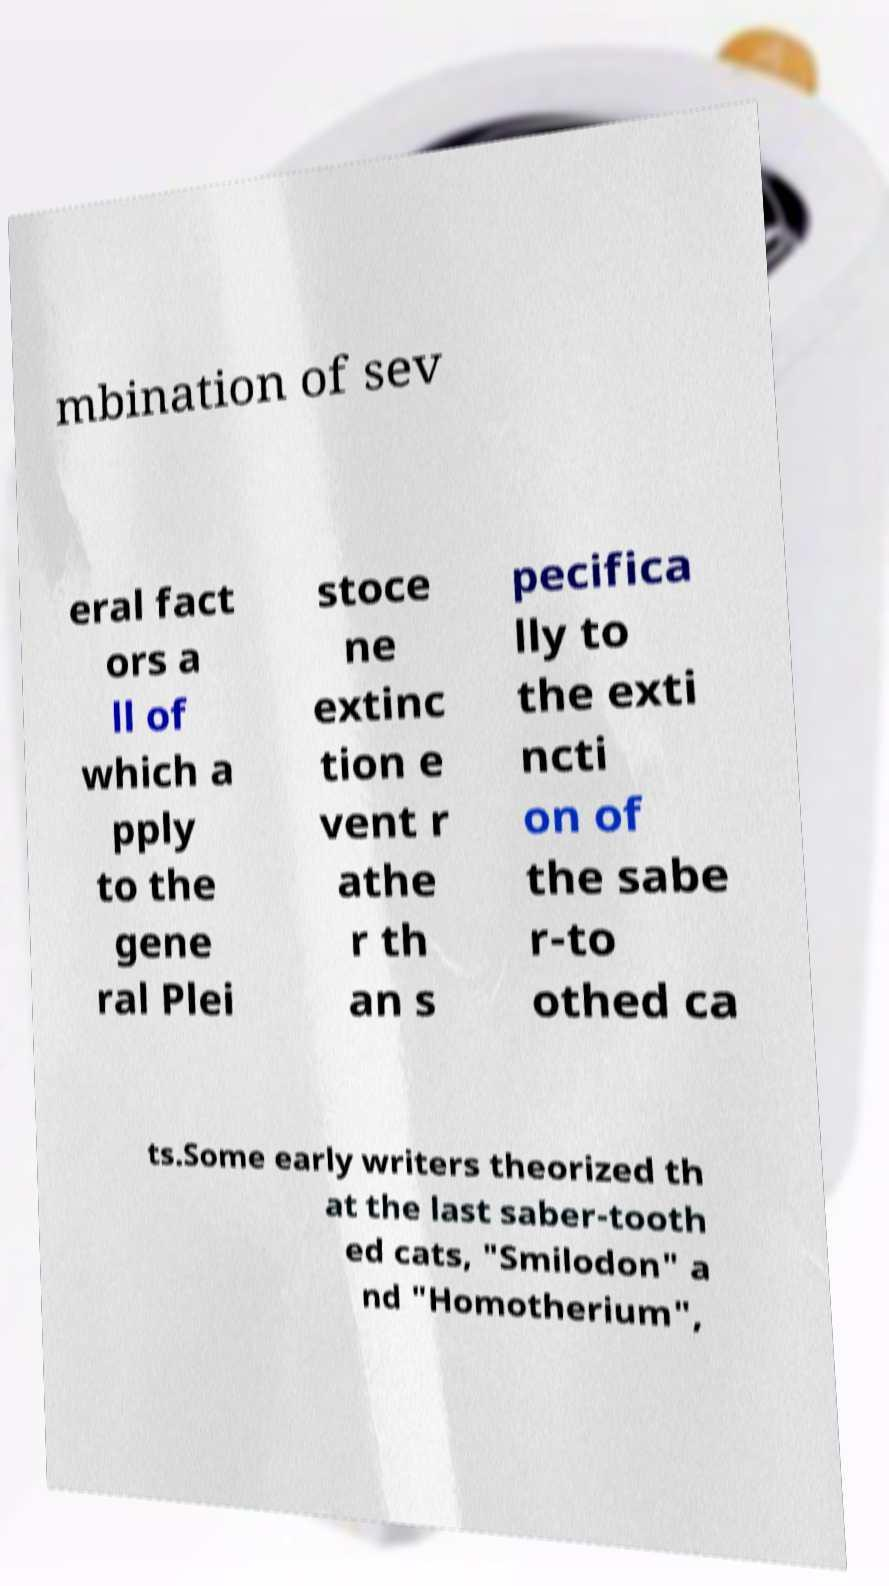For documentation purposes, I need the text within this image transcribed. Could you provide that? mbination of sev eral fact ors a ll of which a pply to the gene ral Plei stoce ne extinc tion e vent r athe r th an s pecifica lly to the exti ncti on of the sabe r-to othed ca ts.Some early writers theorized th at the last saber-tooth ed cats, "Smilodon" a nd "Homotherium", 